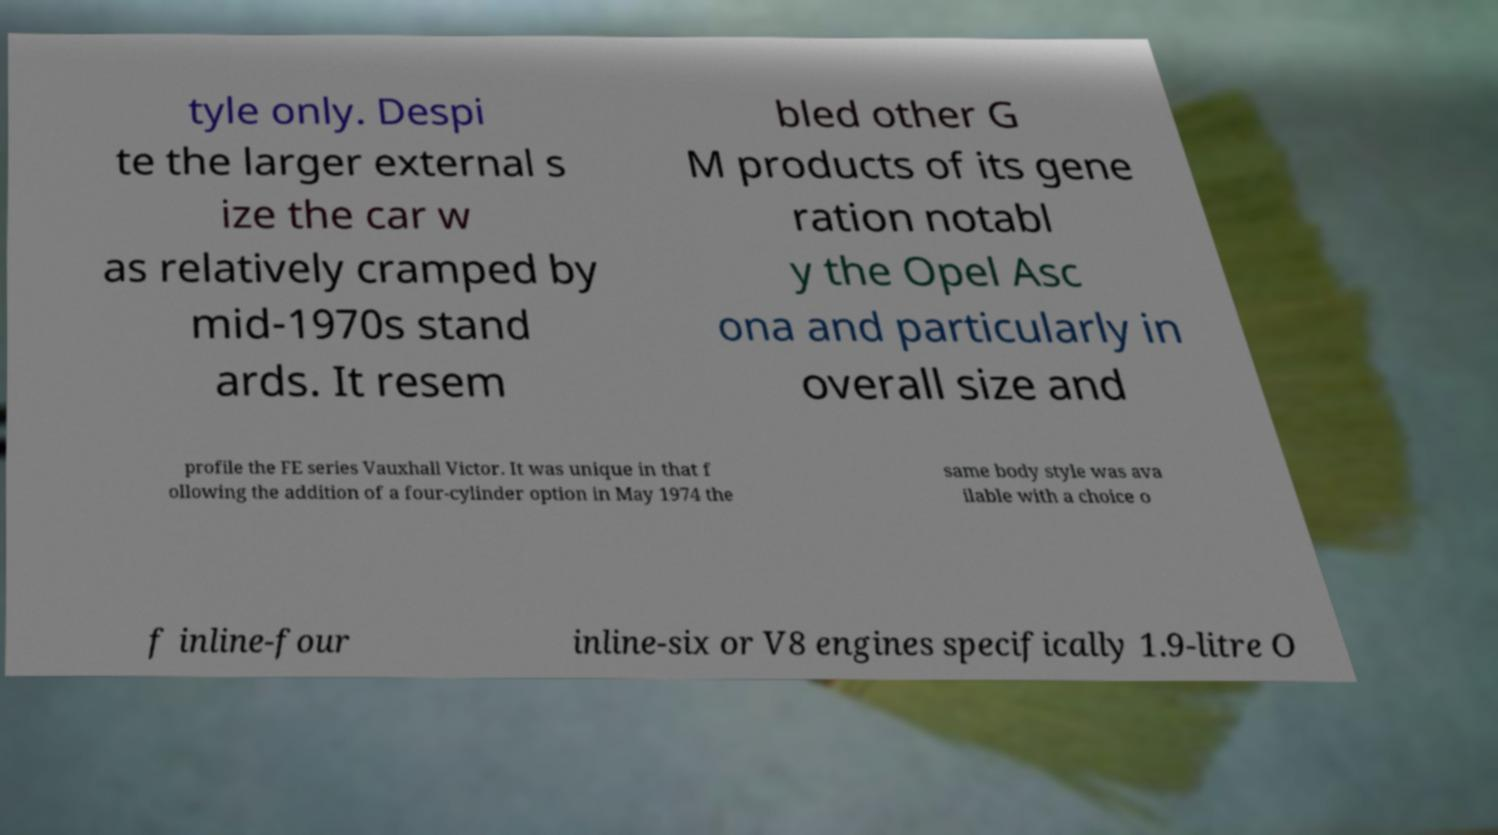I need the written content from this picture converted into text. Can you do that? tyle only. Despi te the larger external s ize the car w as relatively cramped by mid-1970s stand ards. It resem bled other G M products of its gene ration notabl y the Opel Asc ona and particularly in overall size and profile the FE series Vauxhall Victor. It was unique in that f ollowing the addition of a four-cylinder option in May 1974 the same body style was ava ilable with a choice o f inline-four inline-six or V8 engines specifically 1.9-litre O 